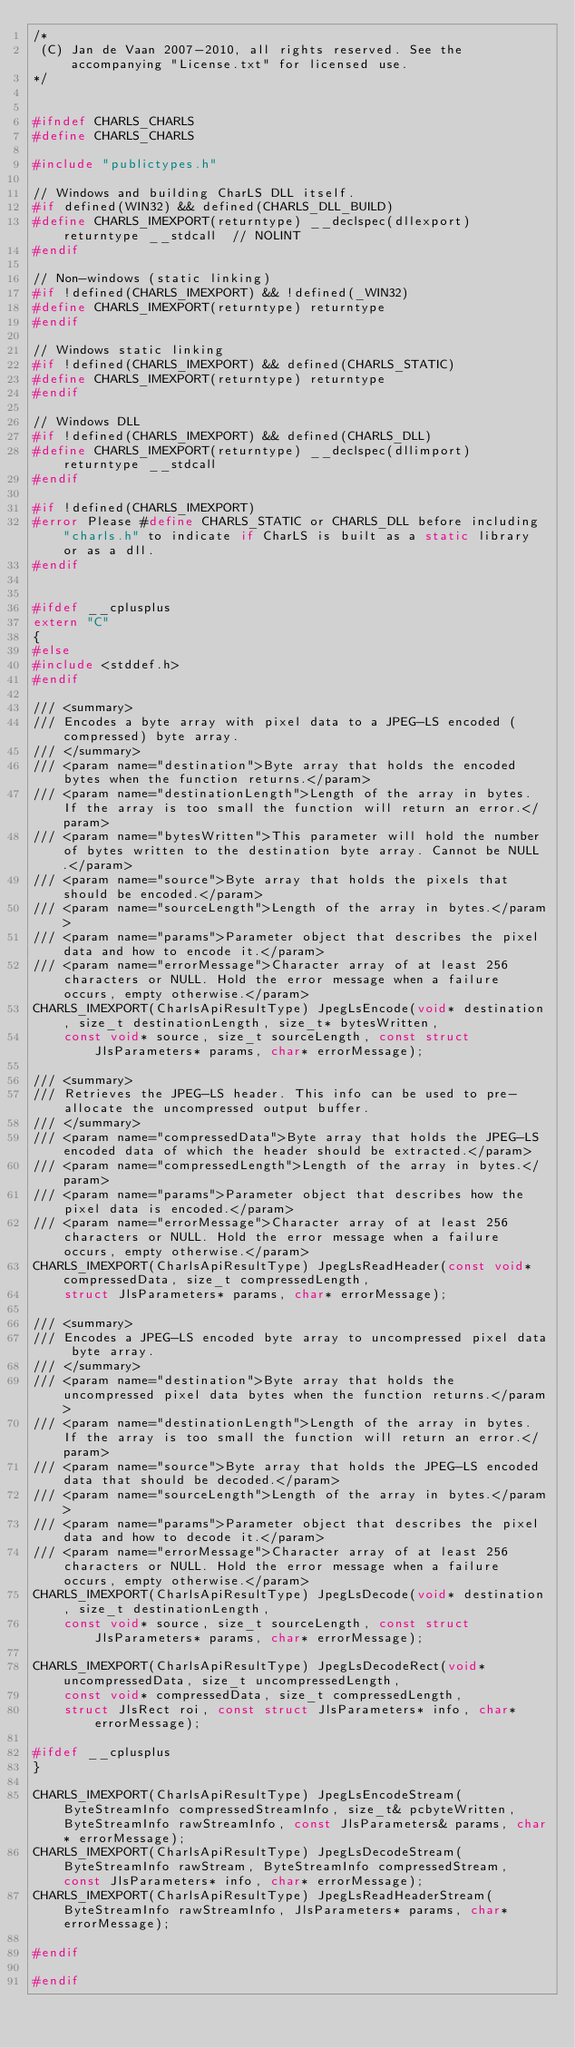<code> <loc_0><loc_0><loc_500><loc_500><_C_>/*
 (C) Jan de Vaan 2007-2010, all rights reserved. See the accompanying "License.txt" for licensed use.
*/


#ifndef CHARLS_CHARLS
#define CHARLS_CHARLS

#include "publictypes.h"

// Windows and building CharLS DLL itself.
#if defined(WIN32) && defined(CHARLS_DLL_BUILD)
#define CHARLS_IMEXPORT(returntype) __declspec(dllexport) returntype __stdcall  // NOLINT
#endif

// Non-windows (static linking)
#if !defined(CHARLS_IMEXPORT) && !defined(_WIN32)
#define CHARLS_IMEXPORT(returntype) returntype
#endif

// Windows static linking
#if !defined(CHARLS_IMEXPORT) && defined(CHARLS_STATIC)
#define CHARLS_IMEXPORT(returntype) returntype
#endif

// Windows DLL
#if !defined(CHARLS_IMEXPORT) && defined(CHARLS_DLL)
#define CHARLS_IMEXPORT(returntype) __declspec(dllimport) returntype __stdcall
#endif

#if !defined(CHARLS_IMEXPORT)
#error Please #define CHARLS_STATIC or CHARLS_DLL before including "charls.h" to indicate if CharLS is built as a static library or as a dll.
#endif


#ifdef __cplusplus
extern "C"
{
#else
#include <stddef.h>
#endif

/// <summary>
/// Encodes a byte array with pixel data to a JPEG-LS encoded (compressed) byte array.
/// </summary>
/// <param name="destination">Byte array that holds the encoded bytes when the function returns.</param>
/// <param name="destinationLength">Length of the array in bytes. If the array is too small the function will return an error.</param>
/// <param name="bytesWritten">This parameter will hold the number of bytes written to the destination byte array. Cannot be NULL.</param>
/// <param name="source">Byte array that holds the pixels that should be encoded.</param>
/// <param name="sourceLength">Length of the array in bytes.</param>
/// <param name="params">Parameter object that describes the pixel data and how to encode it.</param>
/// <param name="errorMessage">Character array of at least 256 characters or NULL. Hold the error message when a failure occurs, empty otherwise.</param>
CHARLS_IMEXPORT(CharlsApiResultType) JpegLsEncode(void* destination, size_t destinationLength, size_t* bytesWritten,
    const void* source, size_t sourceLength, const struct JlsParameters* params, char* errorMessage);

/// <summary>
/// Retrieves the JPEG-LS header. This info can be used to pre-allocate the uncompressed output buffer.
/// </summary>
/// <param name="compressedData">Byte array that holds the JPEG-LS encoded data of which the header should be extracted.</param>
/// <param name="compressedLength">Length of the array in bytes.</param>
/// <param name="params">Parameter object that describes how the pixel data is encoded.</param>
/// <param name="errorMessage">Character array of at least 256 characters or NULL. Hold the error message when a failure occurs, empty otherwise.</param>
CHARLS_IMEXPORT(CharlsApiResultType) JpegLsReadHeader(const void* compressedData, size_t compressedLength,
    struct JlsParameters* params, char* errorMessage);

/// <summary>
/// Encodes a JPEG-LS encoded byte array to uncompressed pixel data byte array.
/// </summary>
/// <param name="destination">Byte array that holds the uncompressed pixel data bytes when the function returns.</param>
/// <param name="destinationLength">Length of the array in bytes. If the array is too small the function will return an error.</param>
/// <param name="source">Byte array that holds the JPEG-LS encoded data that should be decoded.</param>
/// <param name="sourceLength">Length of the array in bytes.</param>
/// <param name="params">Parameter object that describes the pixel data and how to decode it.</param>
/// <param name="errorMessage">Character array of at least 256 characters or NULL. Hold the error message when a failure occurs, empty otherwise.</param>
CHARLS_IMEXPORT(CharlsApiResultType) JpegLsDecode(void* destination, size_t destinationLength,
    const void* source, size_t sourceLength, const struct JlsParameters* params, char* errorMessage);

CHARLS_IMEXPORT(CharlsApiResultType) JpegLsDecodeRect(void* uncompressedData, size_t uncompressedLength,
    const void* compressedData, size_t compressedLength,
    struct JlsRect roi, const struct JlsParameters* info, char* errorMessage);

#ifdef __cplusplus
}

CHARLS_IMEXPORT(CharlsApiResultType) JpegLsEncodeStream(ByteStreamInfo compressedStreamInfo, size_t& pcbyteWritten, ByteStreamInfo rawStreamInfo, const JlsParameters& params, char* errorMessage);
CHARLS_IMEXPORT(CharlsApiResultType) JpegLsDecodeStream(ByteStreamInfo rawStream, ByteStreamInfo compressedStream, const JlsParameters* info, char* errorMessage);
CHARLS_IMEXPORT(CharlsApiResultType) JpegLsReadHeaderStream(ByteStreamInfo rawStreamInfo, JlsParameters* params, char* errorMessage);

#endif

#endif
</code> 